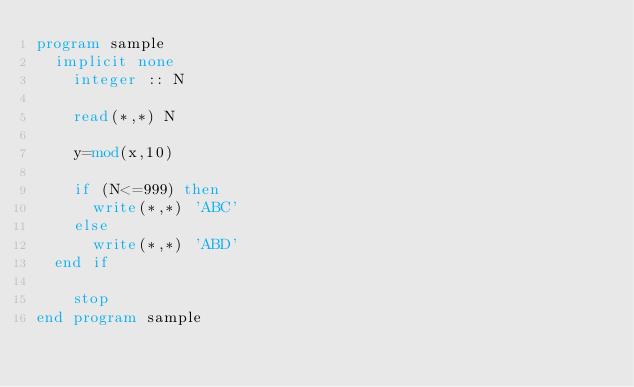Convert code to text. <code><loc_0><loc_0><loc_500><loc_500><_FORTRAN_>program sample
	implicit none
    integer :: N
    
    read(*,*) N
    
    y=mod(x,10)
    
    if (N<=999) then
    	write(*,*) 'ABC'
    else
    	write(*,*) 'ABD'
	end if

    stop
end program sample

</code> 